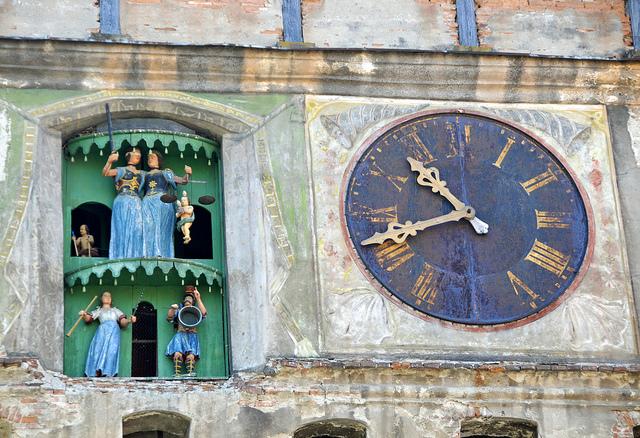What time is it?
Give a very brief answer. 10:42. What is the clock for?
Keep it brief. Telling time. Is this clock brand new?
Keep it brief. No. 